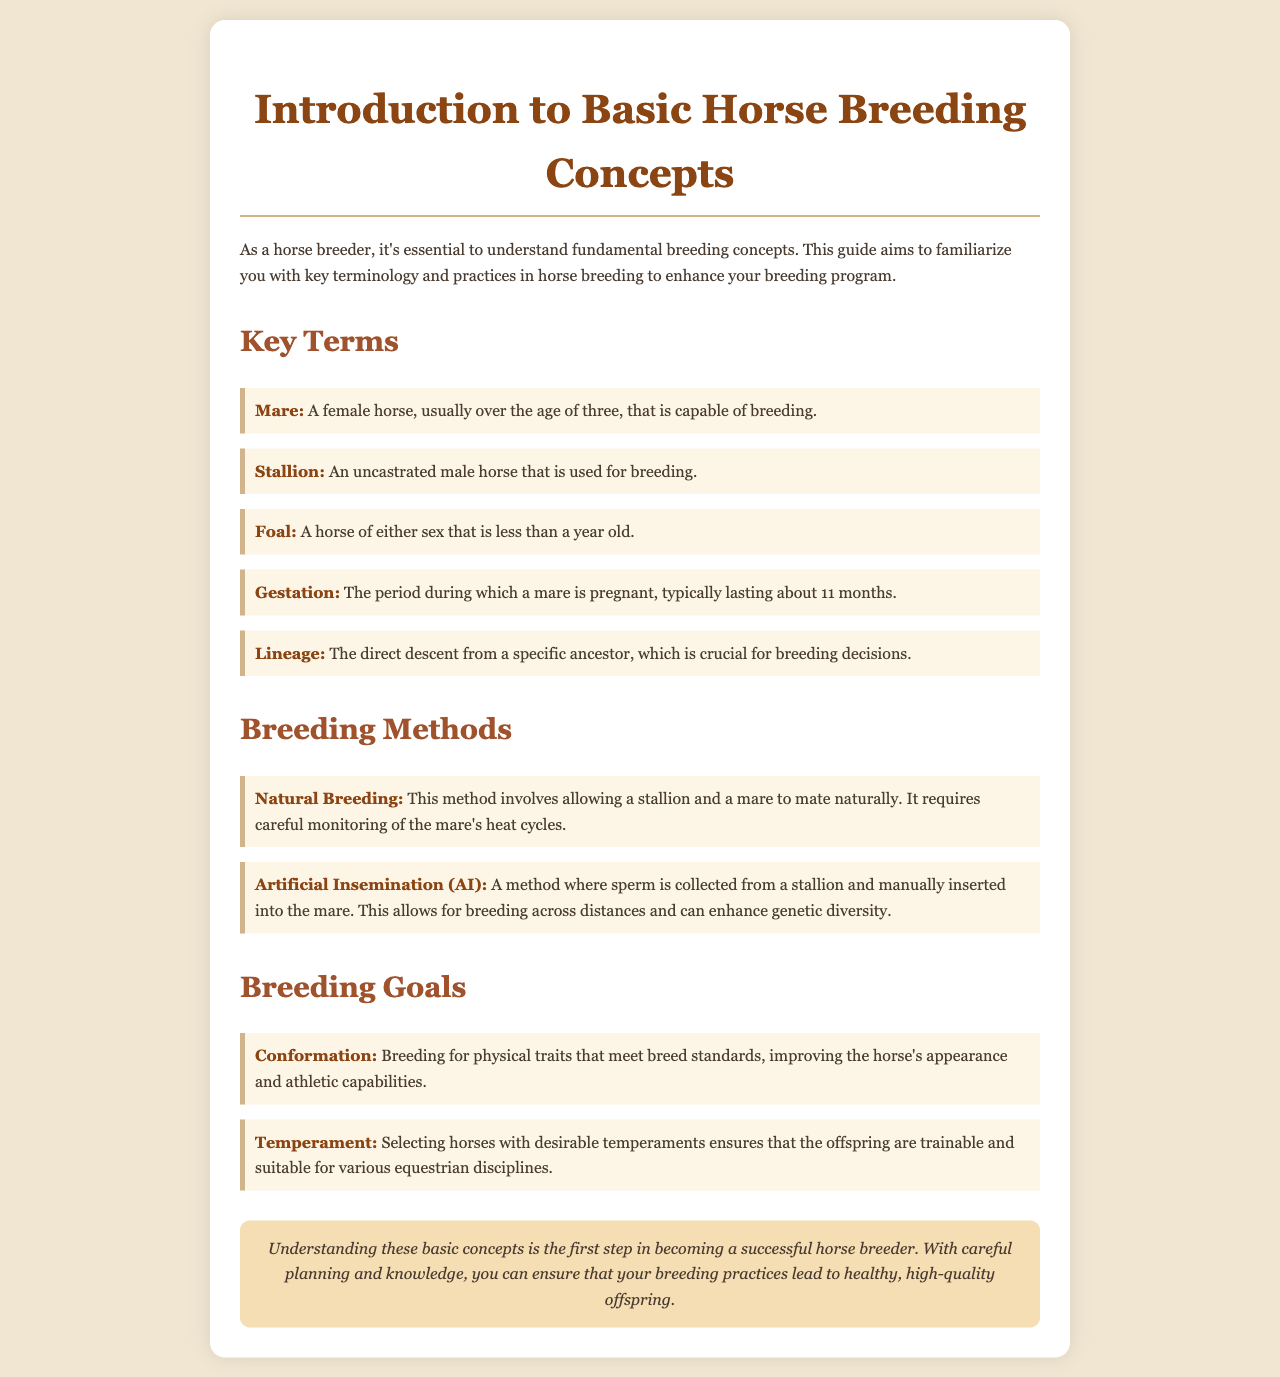What is a mare? A mare is defined in the document as a female horse, usually over the age of three, that is capable of breeding.
Answer: A female horse What is the gestation period for a mare? The document states that the gestation period typically lasts about 11 months.
Answer: 11 months What is artificial insemination? The document describes artificial insemination as a method where sperm is collected from a stallion and manually inserted into the mare.
Answer: Sperm collection and insertion What is one goal of horse breeding mentioned? The document lists breeding goals, such as conformation, aiming to improve the horse's appearance and athletic capabilities.
Answer: Conformation What does lineage refer to in horse breeding? Lineage is described in the document as the direct descent from a specific ancestor, which is crucial for breeding decisions.
Answer: Direct descent What is a stallion? According to the document, a stallion is an uncastrated male horse that is used for breeding.
Answer: An uncastrated male horse What fundamental concepts does the document aim to explain? The document aims to familiarize readers with key terminology and practices in horse breeding to enhance their breeding program.
Answer: Key terminology and practices How can breeding enhance genetic diversity? The document mentions that artificial insemination allows for breeding across distances and can enhance genetic diversity.
Answer: Breeding across distances What is the primary focus of this guide? The primary focus of the guide is to introduce basic horse breeding concepts to beginners.
Answer: Basic horse breeding concepts 